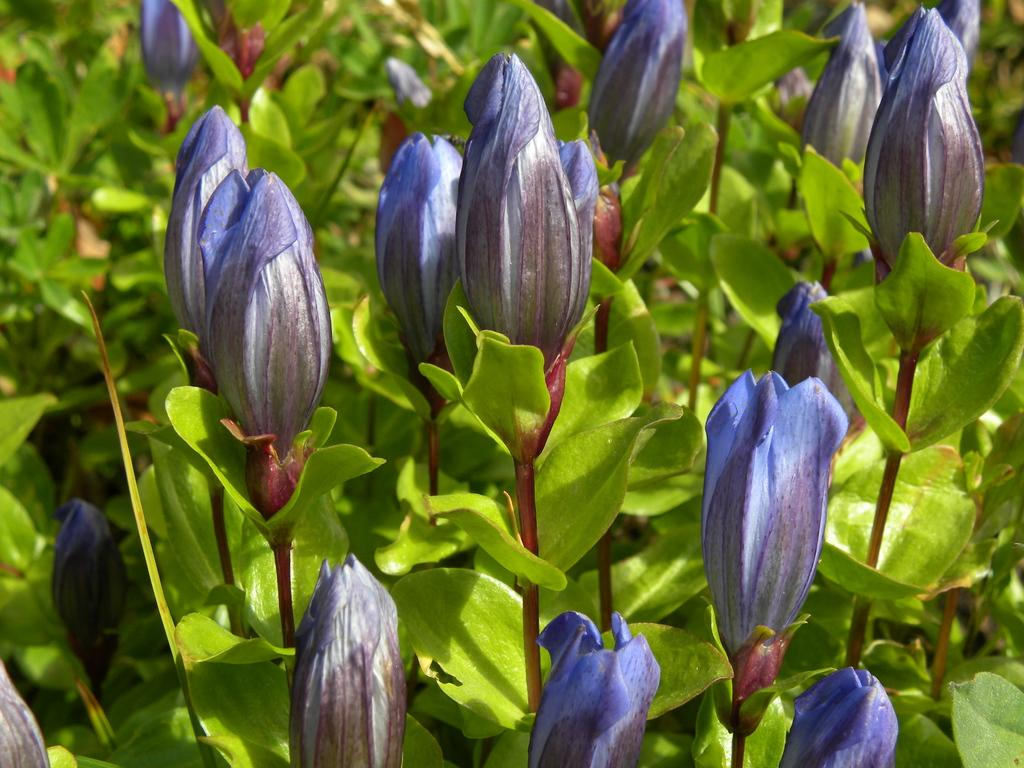What type of living organisms can be seen in the image? Plants and flowers can be seen in the image. Can you describe the flowers in the image? Yes, there are flowers in the image. How many children are playing with the tomatoes in the image? There are no children or tomatoes present in the image. What type of wine is being served in the image? There is no wine present in the image. 